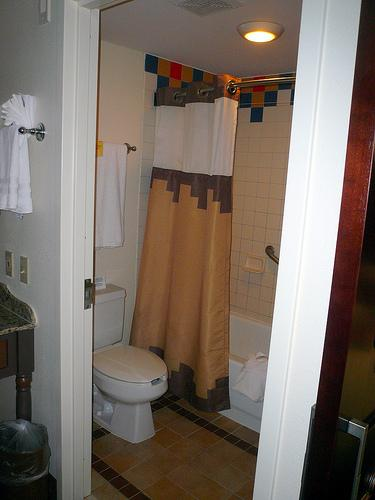Depict the design and color scheme of the bathroom in the image. The bathroom has a mix of white, yellow, and a colorful tile border featuring red and blue, with yellow tiled floor and white walls. Describe the details related to the light and ventilation in the bathroom image. There is a light fixture on the ceiling in the top right area while a square vent is also located at the ceiling, slightly towards the left side. Name three objects in the image that are related to hygiene and their positions. A white towel hanging on the towel rack near the center, a soap dish over the bathtub, and a white wash rag near the bottom right corner. Explain the central components of the image in a poetic manner. In a room of white and hues of gold, a bathtub nestles gracefully, while the curtain whispers stories and the toilet stands guard, ever so faithfully. Identify three main objects in the bathroom image and describe their color and position. A white bathtub is located in the bottom center of the image, a white toilet is placed to the left, and a brown and white shower curtain is hanging on the top right side. What are some essentials that are present in the bathroom and where are they located? A towel rack with a white towel hanging in the middle area of the image, a soap dish over the bathtub, and a light switch on the left wall. Imagine you enter the bathroom, what are the first three objects you notice? I notice a white bathtub, a toilet with the seat on, and a hanging white towel on the towel rack. Describe the style and organization of the bathroom in the image.  The bathroom has a cozy and friendly design, with a mix of colorful tiles, functional organization, and essential items for daily use. Express the atmosphere of the bathroom in one sentence. The bathroom's yellow tiled floor and colorful tile border give it a warm and cheerful atmosphere. State the three main colors you can observe in the image and which objects they belong to. White - bathtub, toilet, and most walls; yellow - tiled floor and some tiles; brown - shower curtain. 